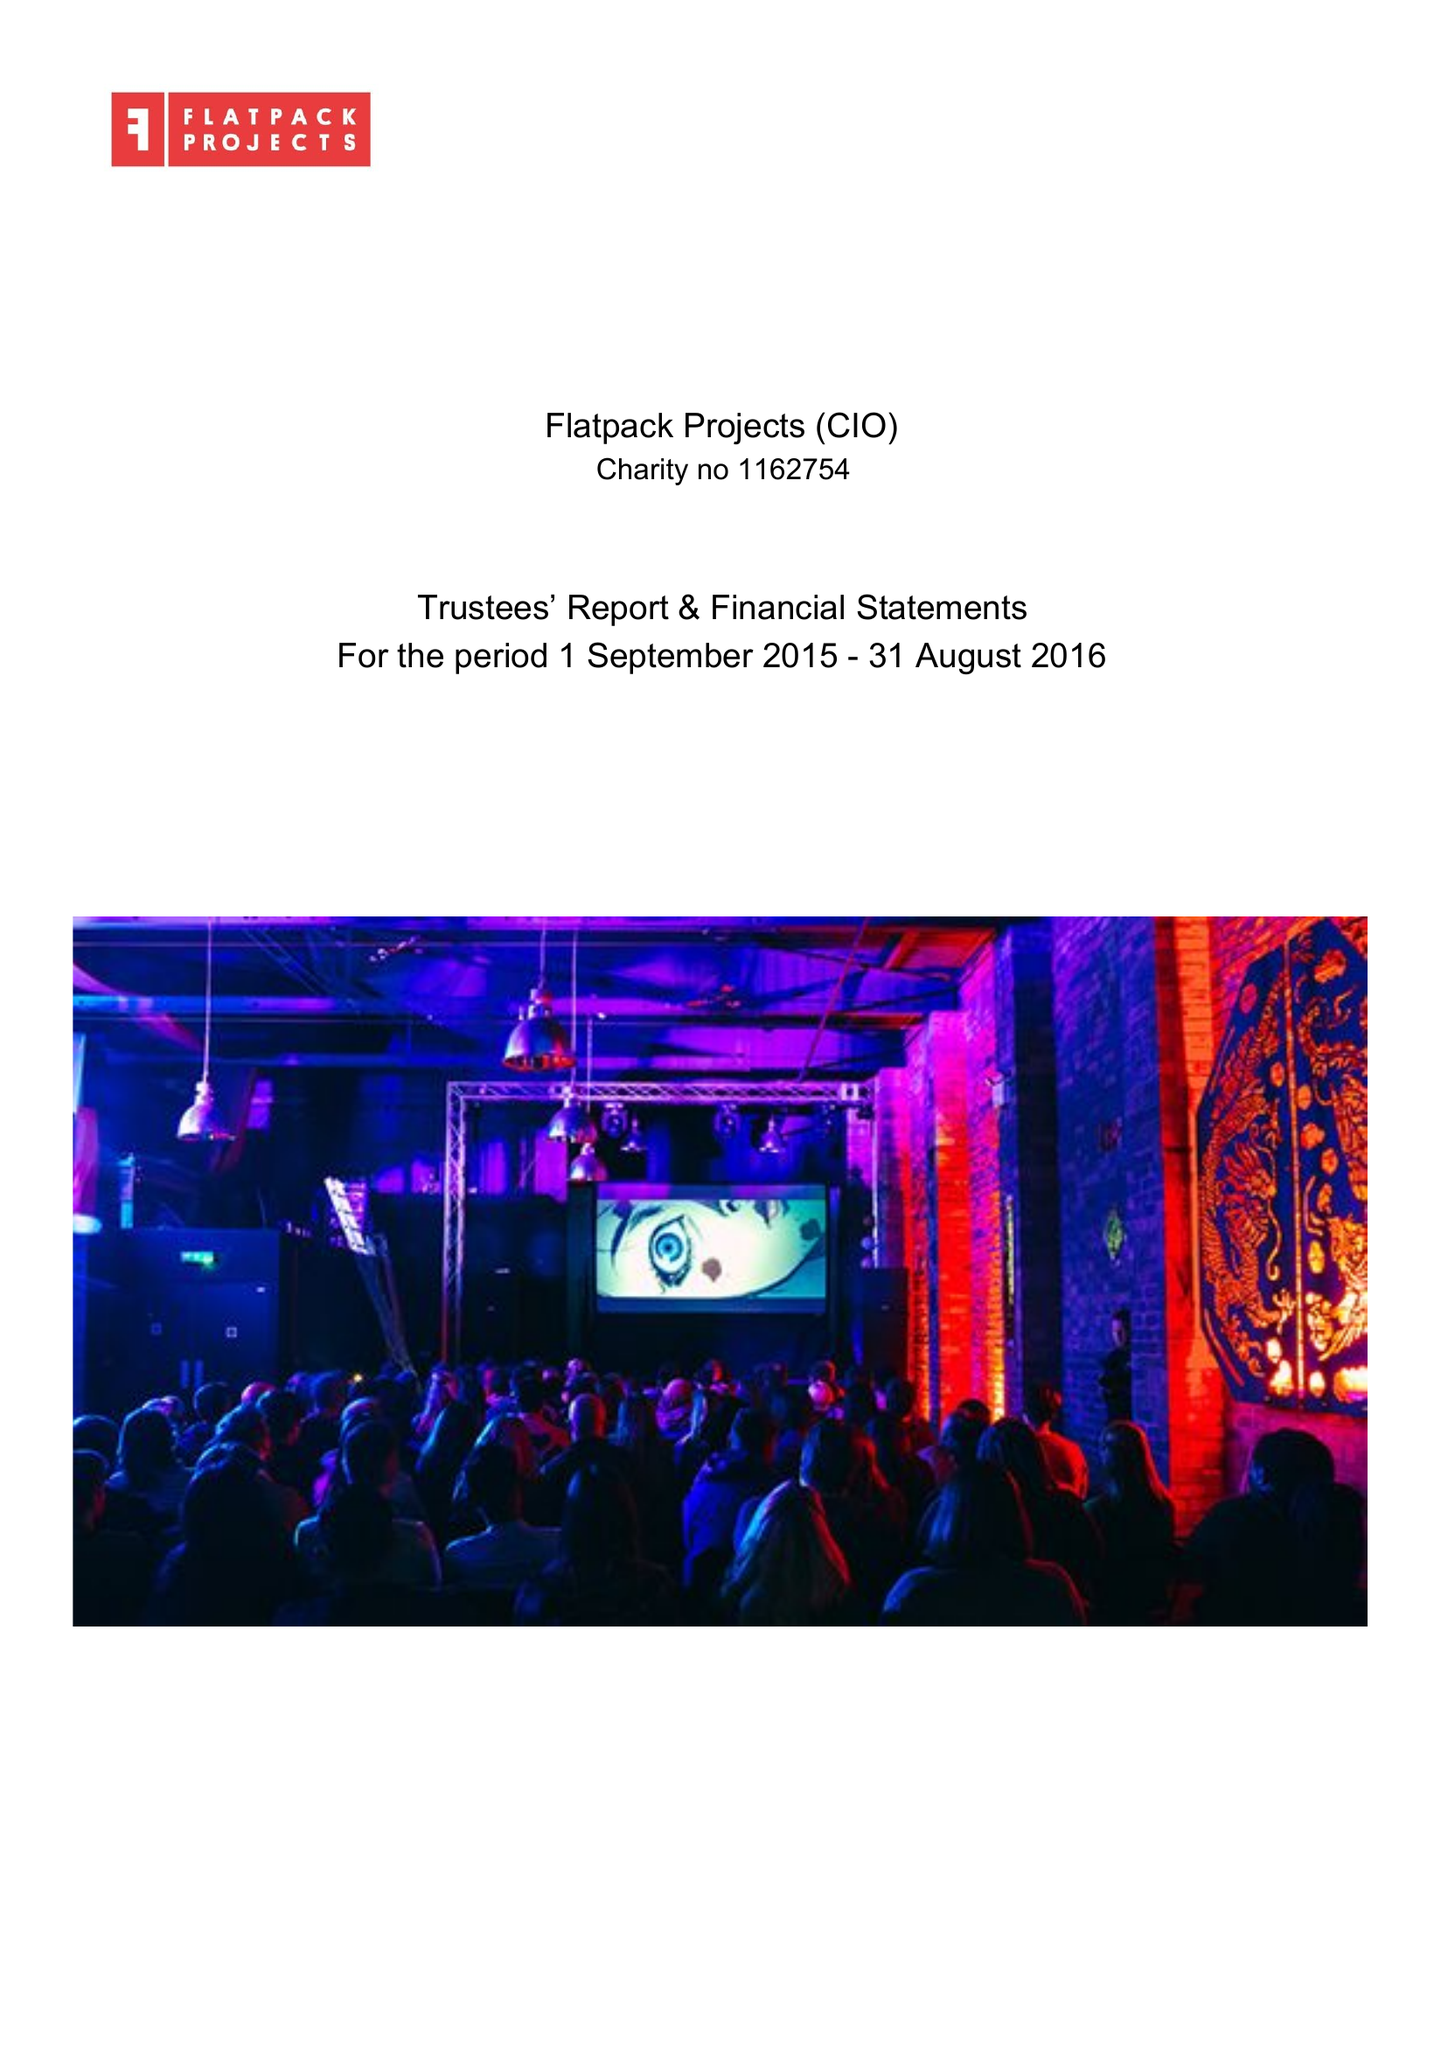What is the value for the address__street_line?
Answer the question using a single word or phrase. None 